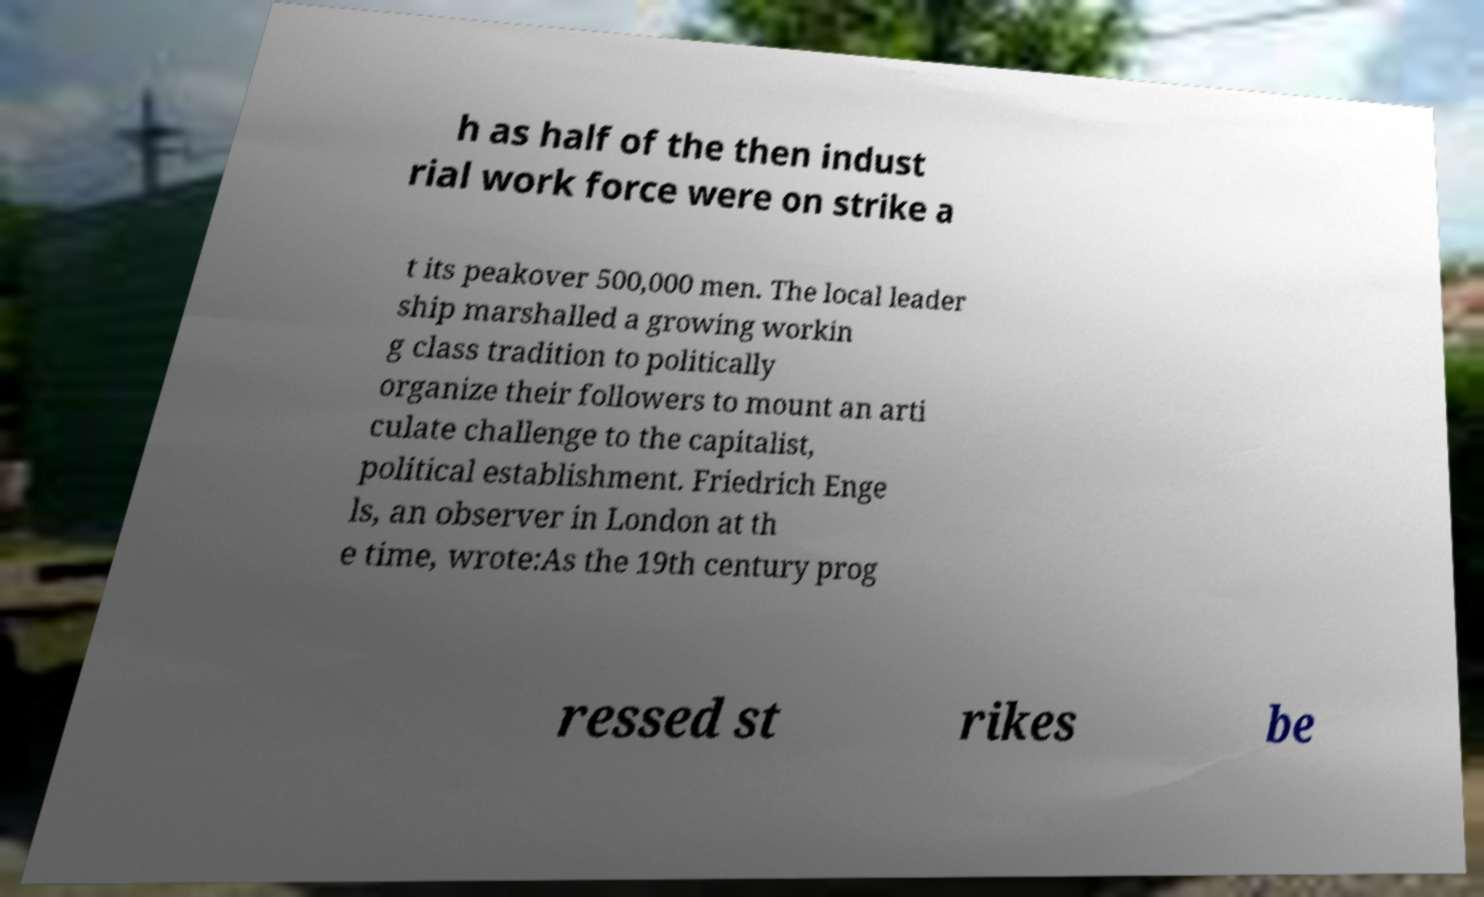Can you accurately transcribe the text from the provided image for me? h as half of the then indust rial work force were on strike a t its peakover 500,000 men. The local leader ship marshalled a growing workin g class tradition to politically organize their followers to mount an arti culate challenge to the capitalist, political establishment. Friedrich Enge ls, an observer in London at th e time, wrote:As the 19th century prog ressed st rikes be 